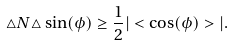<formula> <loc_0><loc_0><loc_500><loc_500>\triangle N \triangle \sin ( \phi ) \geq \frac { 1 } { 2 } | < \cos ( \phi ) > | .</formula> 